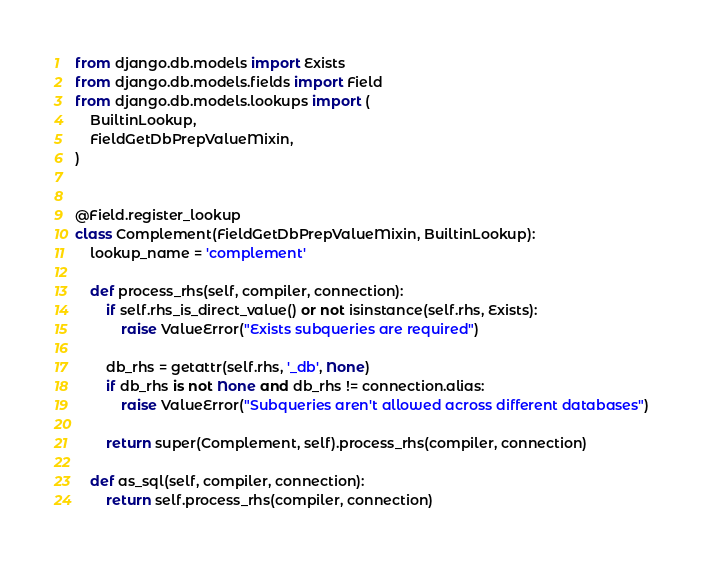<code> <loc_0><loc_0><loc_500><loc_500><_Python_>from django.db.models import Exists
from django.db.models.fields import Field
from django.db.models.lookups import (
    BuiltinLookup,
    FieldGetDbPrepValueMixin,
)


@Field.register_lookup
class Complement(FieldGetDbPrepValueMixin, BuiltinLookup):
    lookup_name = 'complement'

    def process_rhs(self, compiler, connection):
        if self.rhs_is_direct_value() or not isinstance(self.rhs, Exists):
            raise ValueError("Exists subqueries are required")

        db_rhs = getattr(self.rhs, '_db', None)
        if db_rhs is not None and db_rhs != connection.alias:
            raise ValueError("Subqueries aren't allowed across different databases")

        return super(Complement, self).process_rhs(compiler, connection)

    def as_sql(self, compiler, connection):
        return self.process_rhs(compiler, connection)
</code> 